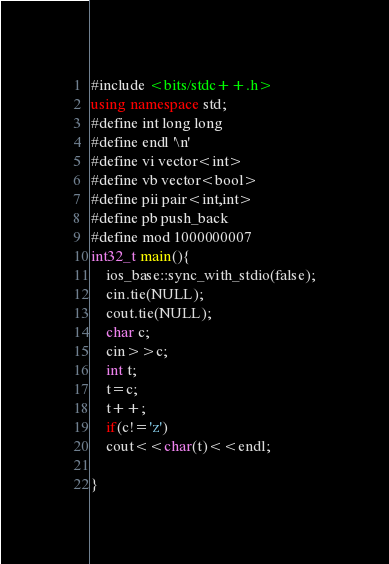Convert code to text. <code><loc_0><loc_0><loc_500><loc_500><_C++_>#include <bits/stdc++.h>
using namespace std;
#define int long long
#define endl '\n'
#define vi vector<int>
#define vb vector<bool>
#define pii pair<int,int>
#define pb push_back
#define mod 1000000007
int32_t main(){
    ios_base::sync_with_stdio(false);
    cin.tie(NULL);
    cout.tie(NULL);
    char c;
    cin>>c;
    int t;
    t=c;
    t++;
    if(c!='z')
    cout<<char(t)<<endl;
    
}</code> 